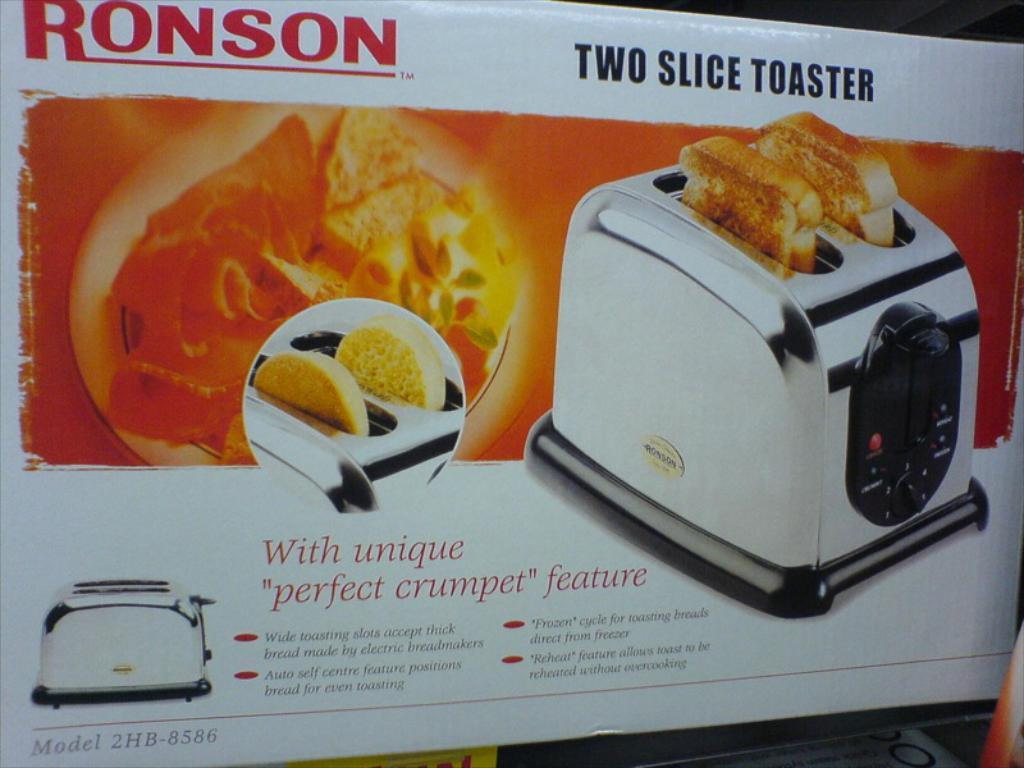<image>
Share a concise interpretation of the image provided. A two slice toaster oven from the company Ronson. 